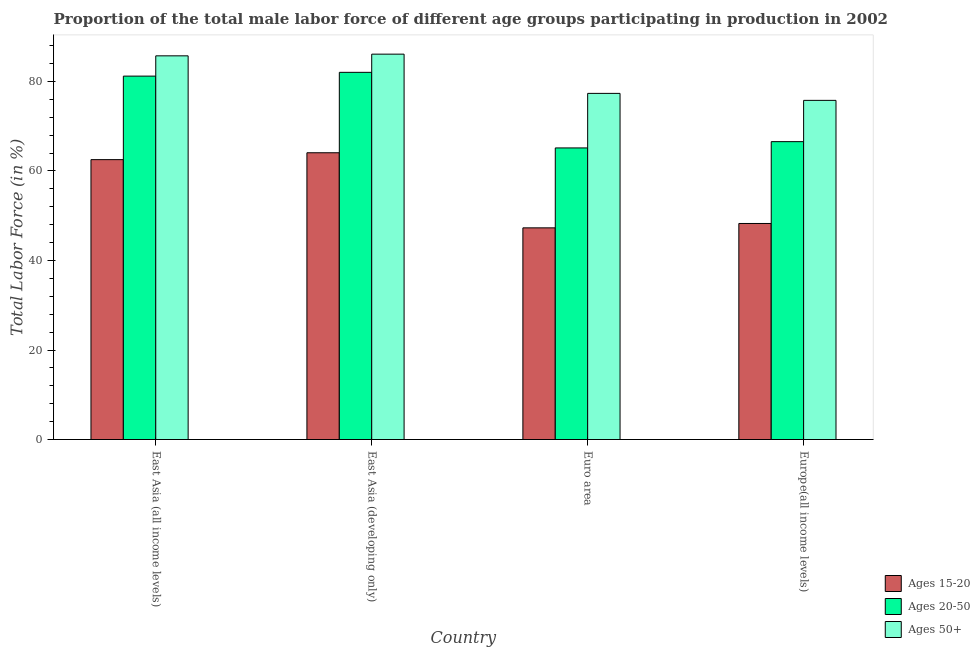Are the number of bars on each tick of the X-axis equal?
Offer a terse response. Yes. How many bars are there on the 2nd tick from the right?
Offer a terse response. 3. What is the label of the 2nd group of bars from the left?
Make the answer very short. East Asia (developing only). What is the percentage of male labor force within the age group 15-20 in Europe(all income levels)?
Your response must be concise. 48.27. Across all countries, what is the maximum percentage of male labor force within the age group 15-20?
Your answer should be compact. 64.07. Across all countries, what is the minimum percentage of male labor force within the age group 15-20?
Keep it short and to the point. 47.29. In which country was the percentage of male labor force within the age group 15-20 maximum?
Your answer should be very brief. East Asia (developing only). What is the total percentage of male labor force within the age group 15-20 in the graph?
Your response must be concise. 222.18. What is the difference between the percentage of male labor force within the age group 15-20 in East Asia (all income levels) and that in Euro area?
Offer a terse response. 15.24. What is the difference between the percentage of male labor force within the age group 15-20 in East Asia (developing only) and the percentage of male labor force above age 50 in Europe(all income levels)?
Offer a terse response. -11.71. What is the average percentage of male labor force above age 50 per country?
Offer a very short reply. 81.24. What is the difference between the percentage of male labor force within the age group 15-20 and percentage of male labor force above age 50 in East Asia (developing only)?
Provide a succinct answer. -22.03. What is the ratio of the percentage of male labor force within the age group 15-20 in East Asia (developing only) to that in Europe(all income levels)?
Your answer should be compact. 1.33. Is the percentage of male labor force within the age group 20-50 in Euro area less than that in Europe(all income levels)?
Provide a succinct answer. Yes. What is the difference between the highest and the second highest percentage of male labor force within the age group 20-50?
Keep it short and to the point. 0.84. What is the difference between the highest and the lowest percentage of male labor force within the age group 20-50?
Your answer should be compact. 16.89. In how many countries, is the percentage of male labor force within the age group 20-50 greater than the average percentage of male labor force within the age group 20-50 taken over all countries?
Ensure brevity in your answer.  2. What does the 3rd bar from the left in East Asia (all income levels) represents?
Your answer should be compact. Ages 50+. What does the 1st bar from the right in Euro area represents?
Offer a terse response. Ages 50+. Is it the case that in every country, the sum of the percentage of male labor force within the age group 15-20 and percentage of male labor force within the age group 20-50 is greater than the percentage of male labor force above age 50?
Provide a succinct answer. Yes. Are all the bars in the graph horizontal?
Give a very brief answer. No. Does the graph contain any zero values?
Offer a very short reply. No. Where does the legend appear in the graph?
Provide a succinct answer. Bottom right. How are the legend labels stacked?
Your response must be concise. Vertical. What is the title of the graph?
Provide a succinct answer. Proportion of the total male labor force of different age groups participating in production in 2002. What is the label or title of the Y-axis?
Provide a succinct answer. Total Labor Force (in %). What is the Total Labor Force (in %) of Ages 15-20 in East Asia (all income levels)?
Offer a terse response. 62.54. What is the Total Labor Force (in %) in Ages 20-50 in East Asia (all income levels)?
Give a very brief answer. 81.2. What is the Total Labor Force (in %) of Ages 50+ in East Asia (all income levels)?
Keep it short and to the point. 85.73. What is the Total Labor Force (in %) of Ages 15-20 in East Asia (developing only)?
Your response must be concise. 64.07. What is the Total Labor Force (in %) in Ages 20-50 in East Asia (developing only)?
Make the answer very short. 82.04. What is the Total Labor Force (in %) in Ages 50+ in East Asia (developing only)?
Provide a short and direct response. 86.11. What is the Total Labor Force (in %) in Ages 15-20 in Euro area?
Provide a succinct answer. 47.29. What is the Total Labor Force (in %) in Ages 20-50 in Euro area?
Your response must be concise. 65.15. What is the Total Labor Force (in %) of Ages 50+ in Euro area?
Your answer should be compact. 77.34. What is the Total Labor Force (in %) in Ages 15-20 in Europe(all income levels)?
Provide a succinct answer. 48.27. What is the Total Labor Force (in %) in Ages 20-50 in Europe(all income levels)?
Provide a short and direct response. 66.56. What is the Total Labor Force (in %) in Ages 50+ in Europe(all income levels)?
Offer a terse response. 75.78. Across all countries, what is the maximum Total Labor Force (in %) in Ages 15-20?
Ensure brevity in your answer.  64.07. Across all countries, what is the maximum Total Labor Force (in %) of Ages 20-50?
Offer a very short reply. 82.04. Across all countries, what is the maximum Total Labor Force (in %) in Ages 50+?
Ensure brevity in your answer.  86.11. Across all countries, what is the minimum Total Labor Force (in %) in Ages 15-20?
Ensure brevity in your answer.  47.29. Across all countries, what is the minimum Total Labor Force (in %) in Ages 20-50?
Provide a succinct answer. 65.15. Across all countries, what is the minimum Total Labor Force (in %) in Ages 50+?
Give a very brief answer. 75.78. What is the total Total Labor Force (in %) of Ages 15-20 in the graph?
Make the answer very short. 222.18. What is the total Total Labor Force (in %) in Ages 20-50 in the graph?
Provide a short and direct response. 294.95. What is the total Total Labor Force (in %) of Ages 50+ in the graph?
Provide a succinct answer. 324.96. What is the difference between the Total Labor Force (in %) in Ages 15-20 in East Asia (all income levels) and that in East Asia (developing only)?
Give a very brief answer. -1.54. What is the difference between the Total Labor Force (in %) in Ages 20-50 in East Asia (all income levels) and that in East Asia (developing only)?
Keep it short and to the point. -0.84. What is the difference between the Total Labor Force (in %) in Ages 50+ in East Asia (all income levels) and that in East Asia (developing only)?
Provide a succinct answer. -0.38. What is the difference between the Total Labor Force (in %) in Ages 15-20 in East Asia (all income levels) and that in Euro area?
Make the answer very short. 15.24. What is the difference between the Total Labor Force (in %) in Ages 20-50 in East Asia (all income levels) and that in Euro area?
Ensure brevity in your answer.  16.05. What is the difference between the Total Labor Force (in %) in Ages 50+ in East Asia (all income levels) and that in Euro area?
Provide a succinct answer. 8.39. What is the difference between the Total Labor Force (in %) in Ages 15-20 in East Asia (all income levels) and that in Europe(all income levels)?
Provide a short and direct response. 14.27. What is the difference between the Total Labor Force (in %) of Ages 20-50 in East Asia (all income levels) and that in Europe(all income levels)?
Make the answer very short. 14.64. What is the difference between the Total Labor Force (in %) of Ages 50+ in East Asia (all income levels) and that in Europe(all income levels)?
Make the answer very short. 9.95. What is the difference between the Total Labor Force (in %) of Ages 15-20 in East Asia (developing only) and that in Euro area?
Offer a terse response. 16.78. What is the difference between the Total Labor Force (in %) of Ages 20-50 in East Asia (developing only) and that in Euro area?
Your answer should be very brief. 16.89. What is the difference between the Total Labor Force (in %) in Ages 50+ in East Asia (developing only) and that in Euro area?
Provide a succinct answer. 8.77. What is the difference between the Total Labor Force (in %) in Ages 15-20 in East Asia (developing only) and that in Europe(all income levels)?
Keep it short and to the point. 15.8. What is the difference between the Total Labor Force (in %) of Ages 20-50 in East Asia (developing only) and that in Europe(all income levels)?
Your response must be concise. 15.49. What is the difference between the Total Labor Force (in %) in Ages 50+ in East Asia (developing only) and that in Europe(all income levels)?
Your answer should be very brief. 10.33. What is the difference between the Total Labor Force (in %) of Ages 15-20 in Euro area and that in Europe(all income levels)?
Offer a very short reply. -0.98. What is the difference between the Total Labor Force (in %) of Ages 20-50 in Euro area and that in Europe(all income levels)?
Offer a terse response. -1.4. What is the difference between the Total Labor Force (in %) in Ages 50+ in Euro area and that in Europe(all income levels)?
Give a very brief answer. 1.56. What is the difference between the Total Labor Force (in %) in Ages 15-20 in East Asia (all income levels) and the Total Labor Force (in %) in Ages 20-50 in East Asia (developing only)?
Ensure brevity in your answer.  -19.5. What is the difference between the Total Labor Force (in %) of Ages 15-20 in East Asia (all income levels) and the Total Labor Force (in %) of Ages 50+ in East Asia (developing only)?
Your answer should be very brief. -23.57. What is the difference between the Total Labor Force (in %) in Ages 20-50 in East Asia (all income levels) and the Total Labor Force (in %) in Ages 50+ in East Asia (developing only)?
Provide a succinct answer. -4.91. What is the difference between the Total Labor Force (in %) in Ages 15-20 in East Asia (all income levels) and the Total Labor Force (in %) in Ages 20-50 in Euro area?
Give a very brief answer. -2.61. What is the difference between the Total Labor Force (in %) of Ages 15-20 in East Asia (all income levels) and the Total Labor Force (in %) of Ages 50+ in Euro area?
Your answer should be very brief. -14.8. What is the difference between the Total Labor Force (in %) in Ages 20-50 in East Asia (all income levels) and the Total Labor Force (in %) in Ages 50+ in Euro area?
Your answer should be compact. 3.86. What is the difference between the Total Labor Force (in %) in Ages 15-20 in East Asia (all income levels) and the Total Labor Force (in %) in Ages 20-50 in Europe(all income levels)?
Ensure brevity in your answer.  -4.02. What is the difference between the Total Labor Force (in %) of Ages 15-20 in East Asia (all income levels) and the Total Labor Force (in %) of Ages 50+ in Europe(all income levels)?
Ensure brevity in your answer.  -13.24. What is the difference between the Total Labor Force (in %) of Ages 20-50 in East Asia (all income levels) and the Total Labor Force (in %) of Ages 50+ in Europe(all income levels)?
Make the answer very short. 5.42. What is the difference between the Total Labor Force (in %) in Ages 15-20 in East Asia (developing only) and the Total Labor Force (in %) in Ages 20-50 in Euro area?
Keep it short and to the point. -1.08. What is the difference between the Total Labor Force (in %) in Ages 15-20 in East Asia (developing only) and the Total Labor Force (in %) in Ages 50+ in Euro area?
Offer a very short reply. -13.27. What is the difference between the Total Labor Force (in %) in Ages 20-50 in East Asia (developing only) and the Total Labor Force (in %) in Ages 50+ in Euro area?
Your response must be concise. 4.7. What is the difference between the Total Labor Force (in %) of Ages 15-20 in East Asia (developing only) and the Total Labor Force (in %) of Ages 20-50 in Europe(all income levels)?
Offer a very short reply. -2.48. What is the difference between the Total Labor Force (in %) in Ages 15-20 in East Asia (developing only) and the Total Labor Force (in %) in Ages 50+ in Europe(all income levels)?
Give a very brief answer. -11.71. What is the difference between the Total Labor Force (in %) of Ages 20-50 in East Asia (developing only) and the Total Labor Force (in %) of Ages 50+ in Europe(all income levels)?
Give a very brief answer. 6.26. What is the difference between the Total Labor Force (in %) in Ages 15-20 in Euro area and the Total Labor Force (in %) in Ages 20-50 in Europe(all income levels)?
Your answer should be very brief. -19.26. What is the difference between the Total Labor Force (in %) of Ages 15-20 in Euro area and the Total Labor Force (in %) of Ages 50+ in Europe(all income levels)?
Give a very brief answer. -28.49. What is the difference between the Total Labor Force (in %) of Ages 20-50 in Euro area and the Total Labor Force (in %) of Ages 50+ in Europe(all income levels)?
Provide a short and direct response. -10.63. What is the average Total Labor Force (in %) in Ages 15-20 per country?
Offer a terse response. 55.54. What is the average Total Labor Force (in %) in Ages 20-50 per country?
Your answer should be compact. 73.74. What is the average Total Labor Force (in %) of Ages 50+ per country?
Ensure brevity in your answer.  81.24. What is the difference between the Total Labor Force (in %) of Ages 15-20 and Total Labor Force (in %) of Ages 20-50 in East Asia (all income levels)?
Make the answer very short. -18.66. What is the difference between the Total Labor Force (in %) in Ages 15-20 and Total Labor Force (in %) in Ages 50+ in East Asia (all income levels)?
Offer a very short reply. -23.19. What is the difference between the Total Labor Force (in %) of Ages 20-50 and Total Labor Force (in %) of Ages 50+ in East Asia (all income levels)?
Make the answer very short. -4.53. What is the difference between the Total Labor Force (in %) in Ages 15-20 and Total Labor Force (in %) in Ages 20-50 in East Asia (developing only)?
Make the answer very short. -17.97. What is the difference between the Total Labor Force (in %) of Ages 15-20 and Total Labor Force (in %) of Ages 50+ in East Asia (developing only)?
Keep it short and to the point. -22.03. What is the difference between the Total Labor Force (in %) in Ages 20-50 and Total Labor Force (in %) in Ages 50+ in East Asia (developing only)?
Your answer should be compact. -4.07. What is the difference between the Total Labor Force (in %) in Ages 15-20 and Total Labor Force (in %) in Ages 20-50 in Euro area?
Make the answer very short. -17.86. What is the difference between the Total Labor Force (in %) of Ages 15-20 and Total Labor Force (in %) of Ages 50+ in Euro area?
Your response must be concise. -30.05. What is the difference between the Total Labor Force (in %) in Ages 20-50 and Total Labor Force (in %) in Ages 50+ in Euro area?
Your answer should be very brief. -12.19. What is the difference between the Total Labor Force (in %) of Ages 15-20 and Total Labor Force (in %) of Ages 20-50 in Europe(all income levels)?
Provide a short and direct response. -18.28. What is the difference between the Total Labor Force (in %) in Ages 15-20 and Total Labor Force (in %) in Ages 50+ in Europe(all income levels)?
Your answer should be compact. -27.51. What is the difference between the Total Labor Force (in %) in Ages 20-50 and Total Labor Force (in %) in Ages 50+ in Europe(all income levels)?
Your response must be concise. -9.22. What is the ratio of the Total Labor Force (in %) of Ages 15-20 in East Asia (all income levels) to that in Euro area?
Your response must be concise. 1.32. What is the ratio of the Total Labor Force (in %) in Ages 20-50 in East Asia (all income levels) to that in Euro area?
Your answer should be very brief. 1.25. What is the ratio of the Total Labor Force (in %) in Ages 50+ in East Asia (all income levels) to that in Euro area?
Offer a very short reply. 1.11. What is the ratio of the Total Labor Force (in %) in Ages 15-20 in East Asia (all income levels) to that in Europe(all income levels)?
Offer a very short reply. 1.3. What is the ratio of the Total Labor Force (in %) in Ages 20-50 in East Asia (all income levels) to that in Europe(all income levels)?
Keep it short and to the point. 1.22. What is the ratio of the Total Labor Force (in %) in Ages 50+ in East Asia (all income levels) to that in Europe(all income levels)?
Offer a very short reply. 1.13. What is the ratio of the Total Labor Force (in %) in Ages 15-20 in East Asia (developing only) to that in Euro area?
Provide a short and direct response. 1.35. What is the ratio of the Total Labor Force (in %) of Ages 20-50 in East Asia (developing only) to that in Euro area?
Keep it short and to the point. 1.26. What is the ratio of the Total Labor Force (in %) in Ages 50+ in East Asia (developing only) to that in Euro area?
Your answer should be very brief. 1.11. What is the ratio of the Total Labor Force (in %) of Ages 15-20 in East Asia (developing only) to that in Europe(all income levels)?
Offer a terse response. 1.33. What is the ratio of the Total Labor Force (in %) of Ages 20-50 in East Asia (developing only) to that in Europe(all income levels)?
Make the answer very short. 1.23. What is the ratio of the Total Labor Force (in %) in Ages 50+ in East Asia (developing only) to that in Europe(all income levels)?
Provide a short and direct response. 1.14. What is the ratio of the Total Labor Force (in %) of Ages 15-20 in Euro area to that in Europe(all income levels)?
Give a very brief answer. 0.98. What is the ratio of the Total Labor Force (in %) in Ages 20-50 in Euro area to that in Europe(all income levels)?
Ensure brevity in your answer.  0.98. What is the ratio of the Total Labor Force (in %) in Ages 50+ in Euro area to that in Europe(all income levels)?
Offer a very short reply. 1.02. What is the difference between the highest and the second highest Total Labor Force (in %) in Ages 15-20?
Offer a very short reply. 1.54. What is the difference between the highest and the second highest Total Labor Force (in %) of Ages 20-50?
Give a very brief answer. 0.84. What is the difference between the highest and the second highest Total Labor Force (in %) of Ages 50+?
Give a very brief answer. 0.38. What is the difference between the highest and the lowest Total Labor Force (in %) of Ages 15-20?
Your answer should be compact. 16.78. What is the difference between the highest and the lowest Total Labor Force (in %) in Ages 20-50?
Offer a very short reply. 16.89. What is the difference between the highest and the lowest Total Labor Force (in %) in Ages 50+?
Your answer should be very brief. 10.33. 